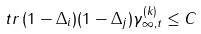<formula> <loc_0><loc_0><loc_500><loc_500>\ t r \, ( 1 - \Delta _ { i } ) ( 1 - \Delta _ { j } ) \gamma ^ { ( k ) } _ { \infty , t } \leq C</formula> 